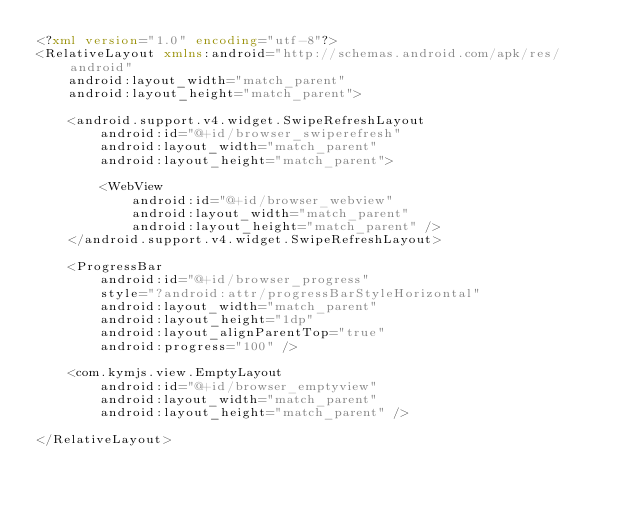<code> <loc_0><loc_0><loc_500><loc_500><_XML_><?xml version="1.0" encoding="utf-8"?>
<RelativeLayout xmlns:android="http://schemas.android.com/apk/res/android"
    android:layout_width="match_parent"
    android:layout_height="match_parent">

    <android.support.v4.widget.SwipeRefreshLayout
        android:id="@+id/browser_swiperefresh"
        android:layout_width="match_parent"
        android:layout_height="match_parent">

        <WebView
            android:id="@+id/browser_webview"
            android:layout_width="match_parent"
            android:layout_height="match_parent" />
    </android.support.v4.widget.SwipeRefreshLayout>

    <ProgressBar
        android:id="@+id/browser_progress"
        style="?android:attr/progressBarStyleHorizontal"
        android:layout_width="match_parent"
        android:layout_height="1dp"
        android:layout_alignParentTop="true"
        android:progress="100" />

    <com.kymjs.view.EmptyLayout
        android:id="@+id/browser_emptyview"
        android:layout_width="match_parent"
        android:layout_height="match_parent" />

</RelativeLayout></code> 